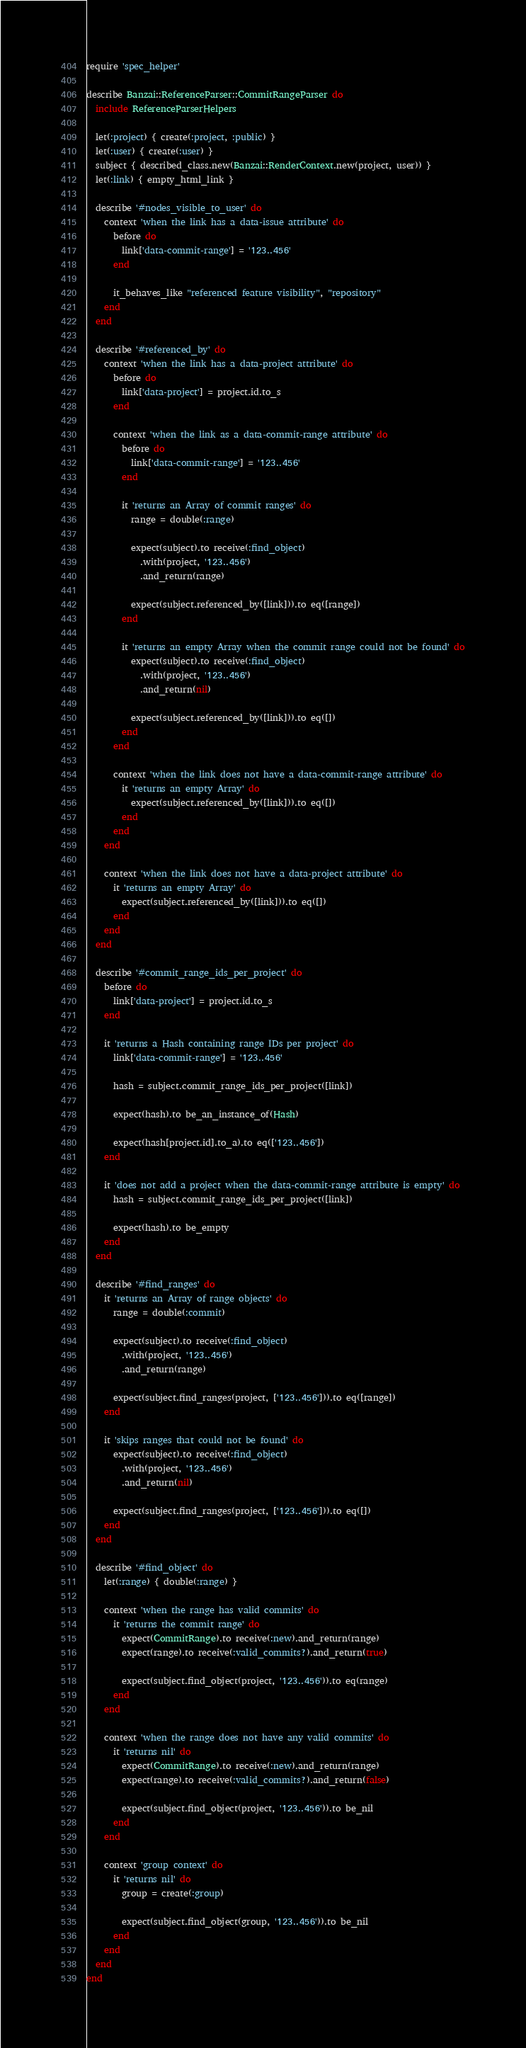<code> <loc_0><loc_0><loc_500><loc_500><_Ruby_>require 'spec_helper'

describe Banzai::ReferenceParser::CommitRangeParser do
  include ReferenceParserHelpers

  let(:project) { create(:project, :public) }
  let(:user) { create(:user) }
  subject { described_class.new(Banzai::RenderContext.new(project, user)) }
  let(:link) { empty_html_link }

  describe '#nodes_visible_to_user' do
    context 'when the link has a data-issue attribute' do
      before do
        link['data-commit-range'] = '123..456'
      end

      it_behaves_like "referenced feature visibility", "repository"
    end
  end

  describe '#referenced_by' do
    context 'when the link has a data-project attribute' do
      before do
        link['data-project'] = project.id.to_s
      end

      context 'when the link as a data-commit-range attribute' do
        before do
          link['data-commit-range'] = '123..456'
        end

        it 'returns an Array of commit ranges' do
          range = double(:range)

          expect(subject).to receive(:find_object)
            .with(project, '123..456')
            .and_return(range)

          expect(subject.referenced_by([link])).to eq([range])
        end

        it 'returns an empty Array when the commit range could not be found' do
          expect(subject).to receive(:find_object)
            .with(project, '123..456')
            .and_return(nil)

          expect(subject.referenced_by([link])).to eq([])
        end
      end

      context 'when the link does not have a data-commit-range attribute' do
        it 'returns an empty Array' do
          expect(subject.referenced_by([link])).to eq([])
        end
      end
    end

    context 'when the link does not have a data-project attribute' do
      it 'returns an empty Array' do
        expect(subject.referenced_by([link])).to eq([])
      end
    end
  end

  describe '#commit_range_ids_per_project' do
    before do
      link['data-project'] = project.id.to_s
    end

    it 'returns a Hash containing range IDs per project' do
      link['data-commit-range'] = '123..456'

      hash = subject.commit_range_ids_per_project([link])

      expect(hash).to be_an_instance_of(Hash)

      expect(hash[project.id].to_a).to eq(['123..456'])
    end

    it 'does not add a project when the data-commit-range attribute is empty' do
      hash = subject.commit_range_ids_per_project([link])

      expect(hash).to be_empty
    end
  end

  describe '#find_ranges' do
    it 'returns an Array of range objects' do
      range = double(:commit)

      expect(subject).to receive(:find_object)
        .with(project, '123..456')
        .and_return(range)

      expect(subject.find_ranges(project, ['123..456'])).to eq([range])
    end

    it 'skips ranges that could not be found' do
      expect(subject).to receive(:find_object)
        .with(project, '123..456')
        .and_return(nil)

      expect(subject.find_ranges(project, ['123..456'])).to eq([])
    end
  end

  describe '#find_object' do
    let(:range) { double(:range) }

    context 'when the range has valid commits' do
      it 'returns the commit range' do
        expect(CommitRange).to receive(:new).and_return(range)
        expect(range).to receive(:valid_commits?).and_return(true)

        expect(subject.find_object(project, '123..456')).to eq(range)
      end
    end

    context 'when the range does not have any valid commits' do
      it 'returns nil' do
        expect(CommitRange).to receive(:new).and_return(range)
        expect(range).to receive(:valid_commits?).and_return(false)

        expect(subject.find_object(project, '123..456')).to be_nil
      end
    end

    context 'group context' do
      it 'returns nil' do
        group = create(:group)

        expect(subject.find_object(group, '123..456')).to be_nil
      end
    end
  end
end
</code> 